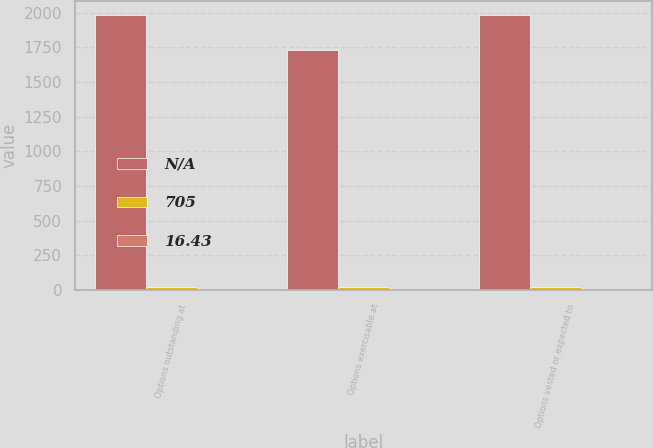Convert chart. <chart><loc_0><loc_0><loc_500><loc_500><stacked_bar_chart><ecel><fcel>Options outstanding at<fcel>Options exercisable at<fcel>Options vested or expected to<nl><fcel>nan<fcel>1986<fcel>1729<fcel>1986<nl><fcel>705<fcel>21.85<fcel>19.42<fcel>21.85<nl><fcel>16.43<fcel>4.55<fcel>4.02<fcel>4.55<nl></chart> 